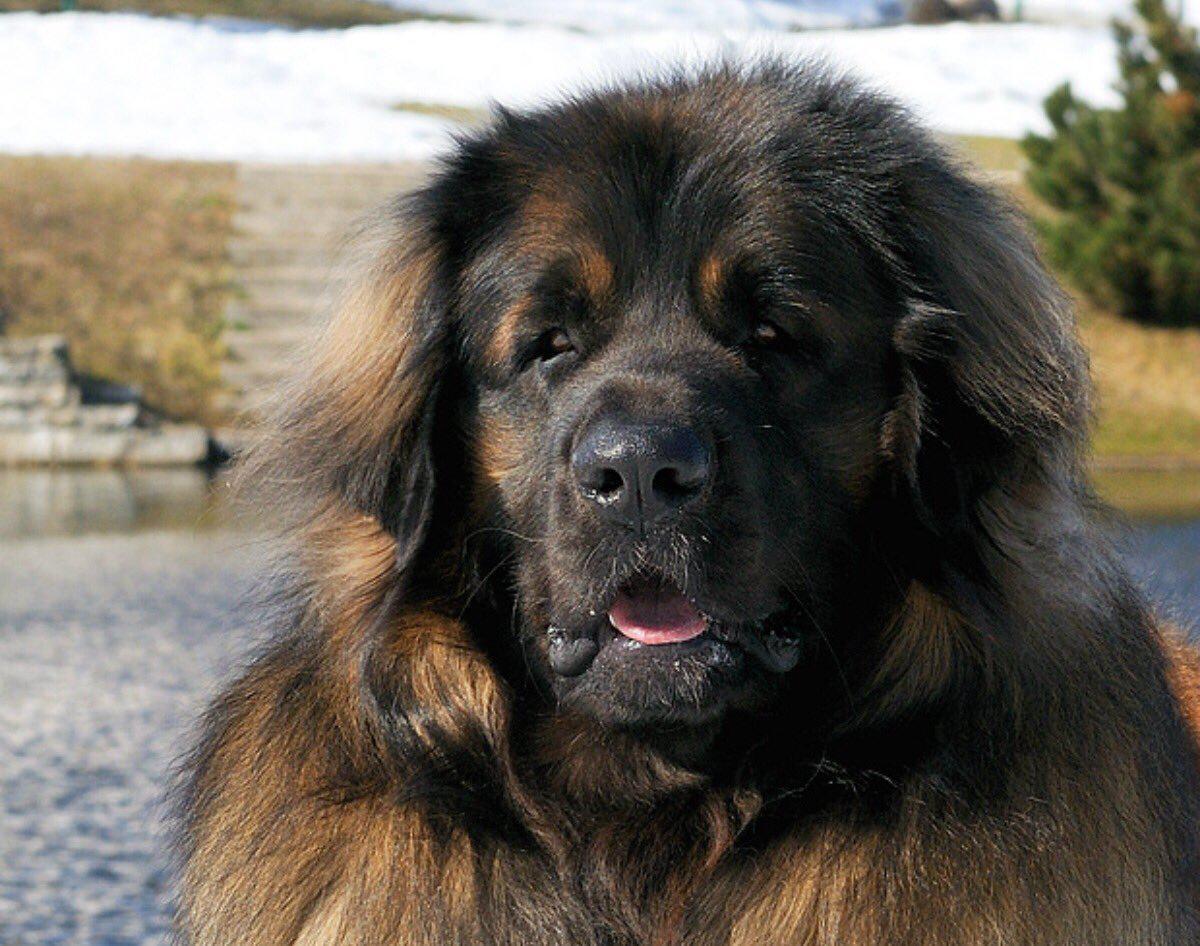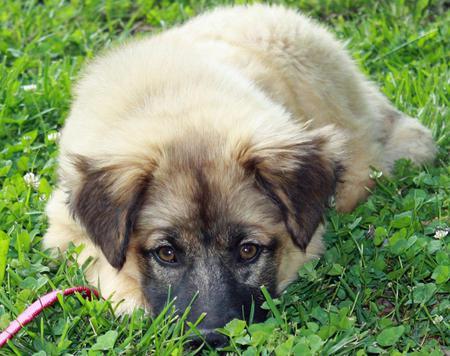The first image is the image on the left, the second image is the image on the right. For the images shown, is this caption "There are three or more dogs." true? Answer yes or no. No. The first image is the image on the left, the second image is the image on the right. Assess this claim about the two images: "An image includes a furry dog lying on green foliage.". Correct or not? Answer yes or no. Yes. 